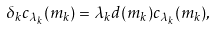<formula> <loc_0><loc_0><loc_500><loc_500>\delta _ { k } c _ { \lambda _ { k } } ( m _ { k } ) = \lambda _ { k } d ( m _ { k } ) c _ { \lambda _ { k } } ( m _ { k } ) ,</formula> 